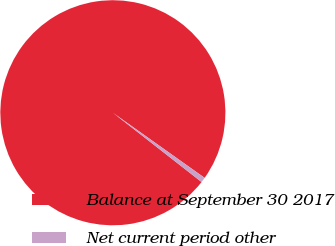<chart> <loc_0><loc_0><loc_500><loc_500><pie_chart><fcel>Balance at September 30 2017<fcel>Net current period other<nl><fcel>99.27%<fcel>0.73%<nl></chart> 